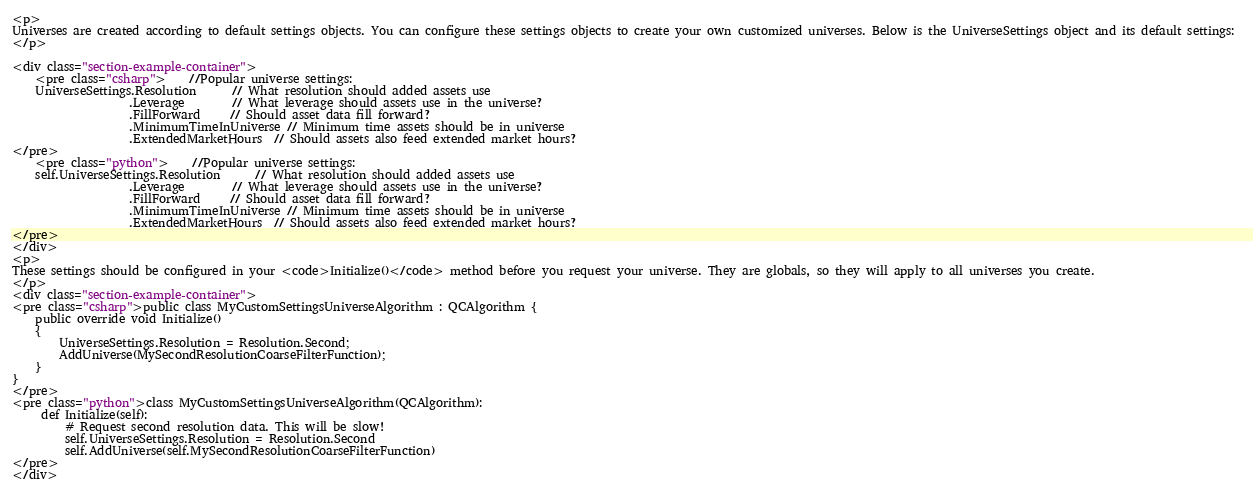<code> <loc_0><loc_0><loc_500><loc_500><_HTML_><p>
Universes are created according to default settings objects. You can configure these settings objects to create your own customized universes. Below is the UniverseSettings object and its default settings: 
</p>

<div class="section-example-container">
	<pre class="csharp">    //Popular universe settings:
    UniverseSettings.Resolution      // What resolution should added assets use
                    .Leverage        // What leverage should assets use in the universe?
                    .FillForward     // Should asset data fill forward?
                    .MinimumTimeInUniverse // Minimum time assets should be in universe
                    .ExtendedMarketHours  // Should assets also feed extended market hours?
</pre>
	<pre class="python">    //Popular universe settings:
    self.UniverseSettings.Resolution      // What resolution should added assets use
                    .Leverage        // What leverage should assets use in the universe?
                    .FillForward     // Should asset data fill forward?
                    .MinimumTimeInUniverse // Minimum time assets should be in universe
                    .ExtendedMarketHours  // Should assets also feed extended market hours?
</pre>
</div>
<p>
These settings should be configured in your <code>Initialize()</code> method before you request your universe. They are globals, so they will apply to all universes you create.
</p>
<div class="section-example-container">
<pre class="csharp">public class MyCustomSettingsUniverseAlgorithm : QCAlgorithm {
    public override void Initialize()
    {
        UniverseSettings.Resolution = Resolution.Second;
        AddUniverse(MySecondResolutionCoarseFilterFunction);
    }
}
</pre>
<pre class="python">class MyCustomSettingsUniverseAlgorithm(QCAlgorithm):
     def Initialize(self):
         # Request second resolution data. This will be slow!
         self.UniverseSettings.Resolution = Resolution.Second
         self.AddUniverse(self.MySecondResolutionCoarseFilterFunction)
</pre>
</div>
</code> 